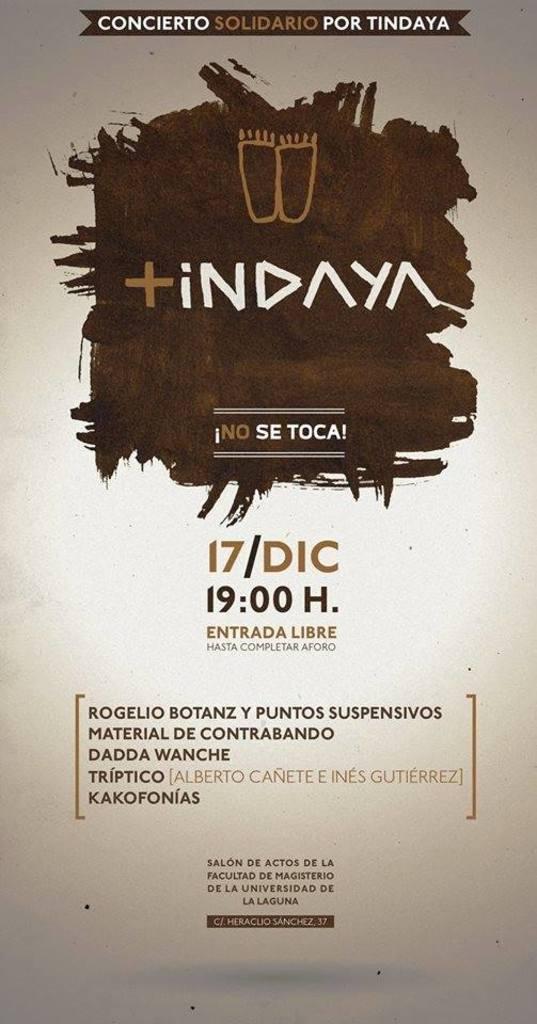What time is the show going to play?
Your answer should be very brief. 19:00. 